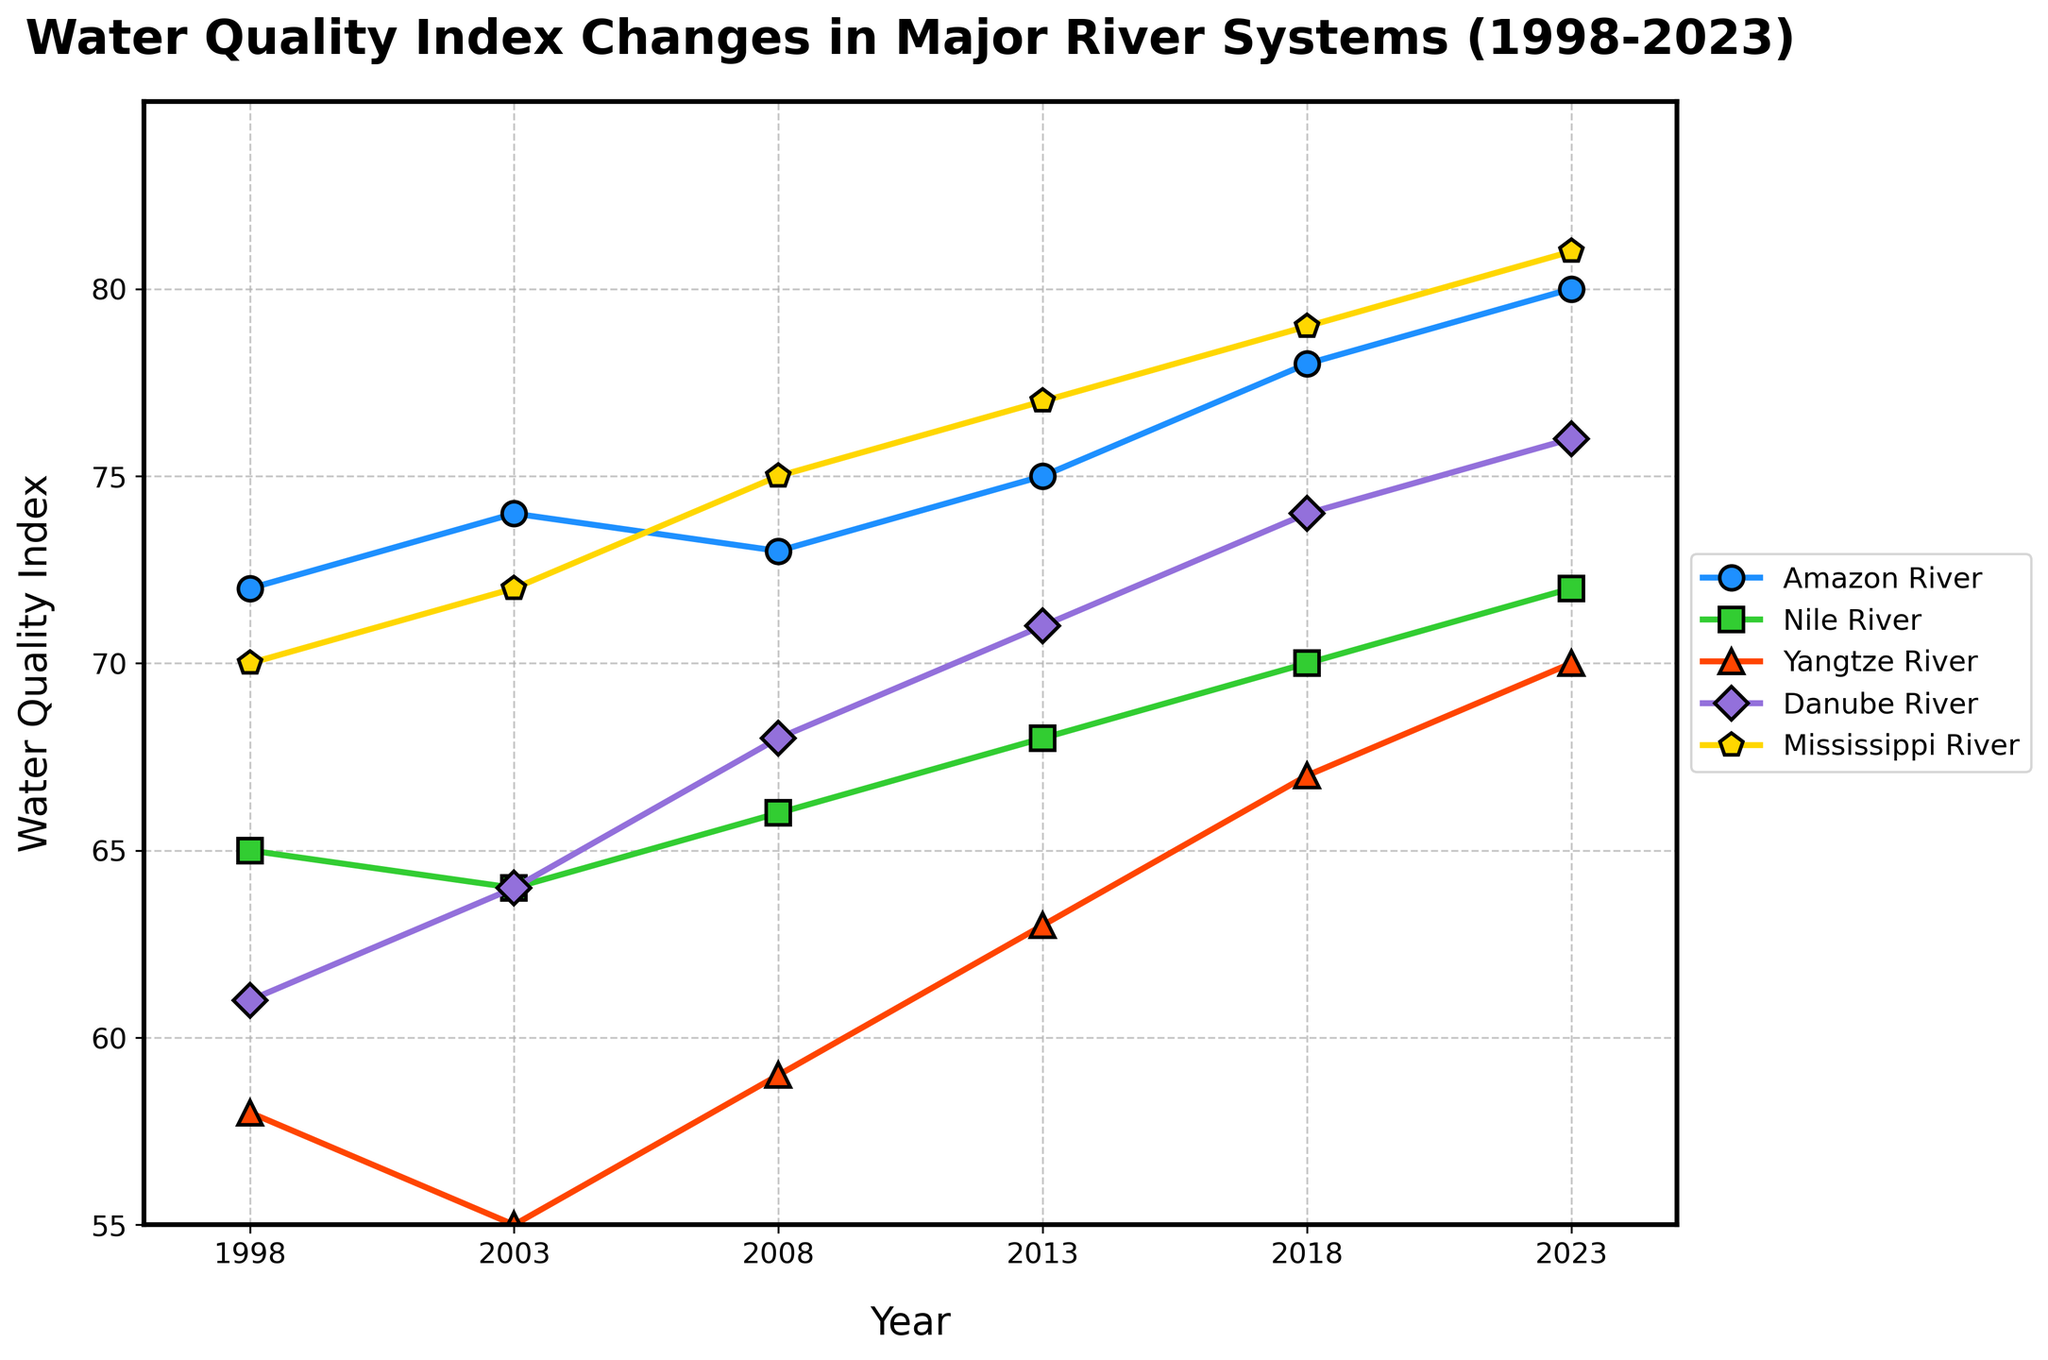How has the Water Quality Index of the Amazon River changed from 1998 to 2023? The plot shows the data points for the Amazon River at each year from 1998 to 2023. The index has increased from 72 in 1998 to 80 in 2023. Thus, the change is 80 - 72 = 8.
Answer: 8 Which river had the highest Water Quality Index in 2023? The plot shows the highest endpoint among all the rivers in 2023. The Mississippi River reaches a value of 81, the highest among the five rivers.
Answer: Mississippi River Between 2003 and 2008, which river showed the largest improvement in the Water Quality Index? We need to check the differences between the values in 2003 and 2008 for each river. The Yangtze River improved from 55 to 59, which is a change of 4, the largest improvement among all rivers during this period.
Answer: Yangtze River What is the average Water Quality Index for the Nile River over the 25 years? The values given for the Nile River are 65, 64, 66, 68, 70, and 72. Summing these values gives 405. Dividing by the 6 data points provides the average, 405 / 6 = 67.5.
Answer: 67.5 By how much did the Water Quality Index of the Danube River increase from 2013 to 2023? The plot shows the data points for the Danube River in 2013 and 2023. The index increased from 71 in 2013 to 76 in 2023. Thus, the increase is 76 - 71 = 5.
Answer: 5 Which river presented the least change in its Water Quality Index between 1998 and 2023? Comparing the differences for each river between 1998 and 2023, we find the smallest change is for the Nile River from 65 to 72, which is a difference of 7.
Answer: Nile River What trend can be observed in the Water Quality Index of the Yangtze River from 1998 to 2023? Observing the plot, the Yangtze River shows a clear upward trend, consistently increasing from 58 in 1998 to 70 in 2023.
Answer: Upward trend Which river's Water Quality Index experienced the greatest improvement in average value between the first half (1998 to 2008) and the second half (2013 to 2023)? Calculate the average for each period: For Amazon River, (72+74+73)/3 = 73 and (75+78+80)/3 = 77.67; for Nile River, (65+64+66)/3 = 65 and (68+70+72)/3 = 70; for Yangtze River, (58+55+59)/3 = 57.33 and (63+67+70)/3 = 66.67; for Danube River, (61+64+68)/3 = 64.33 and (71+74+76)/3 = 73.67; for Mississippi River, (70+72+75)/3 = 72.33 and (77+79+81)/3 = 79. The greatest difference is for the Yangtze River, increasing by 9.34.
Answer: Yangtze River How does the Water Quality Index improvement rate of the Mississippi River compare to that of the Amazon River from 2013 to 2023? The Mississippi River improved from 77 to 81, which is an increase of 4. The Amazon River improved from 75 to 80, which is an increase of 5. Thus, the Amazon River had a higher improvement rate.
Answer: Amazon River 